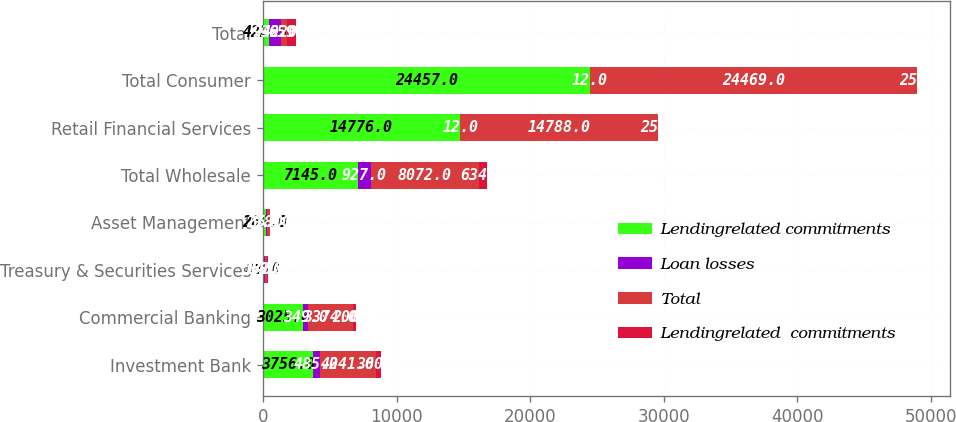Convert chart to OTSL. <chart><loc_0><loc_0><loc_500><loc_500><stacked_bar_chart><ecel><fcel>Investment Bank<fcel>Commercial Banking<fcel>Treasury & Securities Services<fcel>Asset Management<fcel>Total Wholesale<fcel>Retail Financial Services<fcel>Total Consumer<fcel>Total<nl><fcel>Lendingrelated commitments<fcel>3756<fcel>3025<fcel>88<fcel>269<fcel>7145<fcel>14776<fcel>24457<fcel>422.5<nl><fcel>Loan losses<fcel>485<fcel>349<fcel>84<fcel>9<fcel>927<fcel>12<fcel>12<fcel>939<nl><fcel>Total<fcel>4241<fcel>3374<fcel>172<fcel>278<fcel>8072<fcel>14788<fcel>24469<fcel>422.5<nl><fcel>Lendingrelated  commitments<fcel>360<fcel>206<fcel>63<fcel>5<fcel>634<fcel>25<fcel>25<fcel>659<nl></chart> 